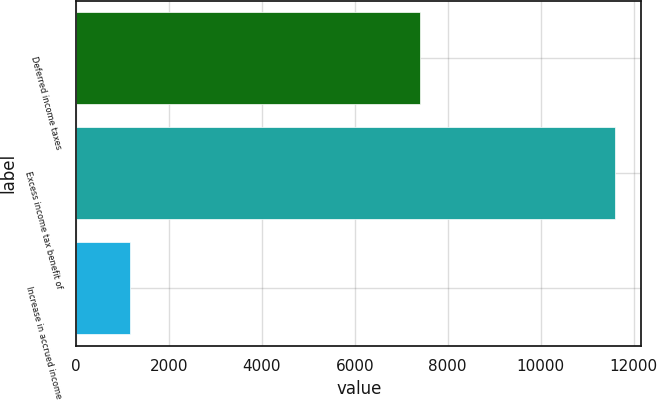<chart> <loc_0><loc_0><loc_500><loc_500><bar_chart><fcel>Deferred income taxes<fcel>Excess income tax benefit of<fcel>Increase in accrued income<nl><fcel>7403<fcel>11590<fcel>1167<nl></chart> 